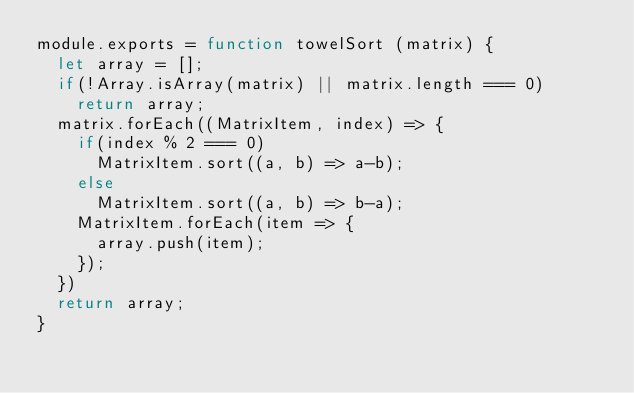<code> <loc_0><loc_0><loc_500><loc_500><_JavaScript_>module.exports = function towelSort (matrix) {
  let array = [];
  if(!Array.isArray(matrix) || matrix.length === 0)
    return array;
  matrix.forEach((MatrixItem, index) => {
    if(index % 2 === 0)
      MatrixItem.sort((a, b) => a-b);
    else
      MatrixItem.sort((a, b) => b-a);
    MatrixItem.forEach(item => {
      array.push(item);
    });
  })
  return array;
}
</code> 